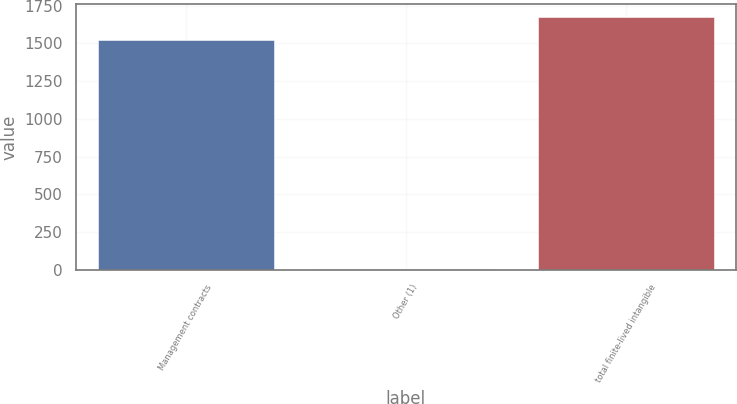<chart> <loc_0><loc_0><loc_500><loc_500><bar_chart><fcel>Management contracts<fcel>Other (1)<fcel>total finite-lived intangible<nl><fcel>1524<fcel>6<fcel>1676.4<nl></chart> 